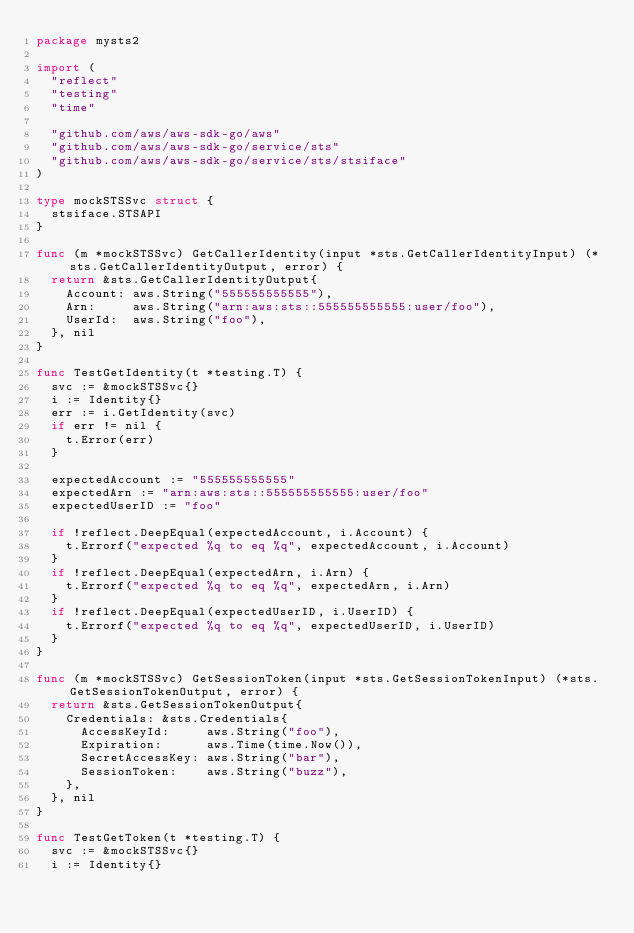Convert code to text. <code><loc_0><loc_0><loc_500><loc_500><_Go_>package mysts2

import (
	"reflect"
	"testing"
	"time"

	"github.com/aws/aws-sdk-go/aws"
	"github.com/aws/aws-sdk-go/service/sts"
	"github.com/aws/aws-sdk-go/service/sts/stsiface"
)

type mockSTSSvc struct {
	stsiface.STSAPI
}

func (m *mockSTSSvc) GetCallerIdentity(input *sts.GetCallerIdentityInput) (*sts.GetCallerIdentityOutput, error) {
	return &sts.GetCallerIdentityOutput{
		Account: aws.String("555555555555"),
		Arn:     aws.String("arn:aws:sts::555555555555:user/foo"),
		UserId:  aws.String("foo"),
	}, nil
}

func TestGetIdentity(t *testing.T) {
	svc := &mockSTSSvc{}
	i := Identity{}
	err := i.GetIdentity(svc)
	if err != nil {
		t.Error(err)
	}

	expectedAccount := "555555555555"
	expectedArn := "arn:aws:sts::555555555555:user/foo"
	expectedUserID := "foo"

	if !reflect.DeepEqual(expectedAccount, i.Account) {
		t.Errorf("expected %q to eq %q", expectedAccount, i.Account)
	}
	if !reflect.DeepEqual(expectedArn, i.Arn) {
		t.Errorf("expected %q to eq %q", expectedArn, i.Arn)
	}
	if !reflect.DeepEqual(expectedUserID, i.UserID) {
		t.Errorf("expected %q to eq %q", expectedUserID, i.UserID)
	}
}

func (m *mockSTSSvc) GetSessionToken(input *sts.GetSessionTokenInput) (*sts.GetSessionTokenOutput, error) {
	return &sts.GetSessionTokenOutput{
		Credentials: &sts.Credentials{
			AccessKeyId:     aws.String("foo"),
			Expiration:      aws.Time(time.Now()),
			SecretAccessKey: aws.String("bar"),
			SessionToken:    aws.String("buzz"),
		},
	}, nil
}

func TestGetToken(t *testing.T) {
	svc := &mockSTSSvc{}
	i := Identity{}</code> 